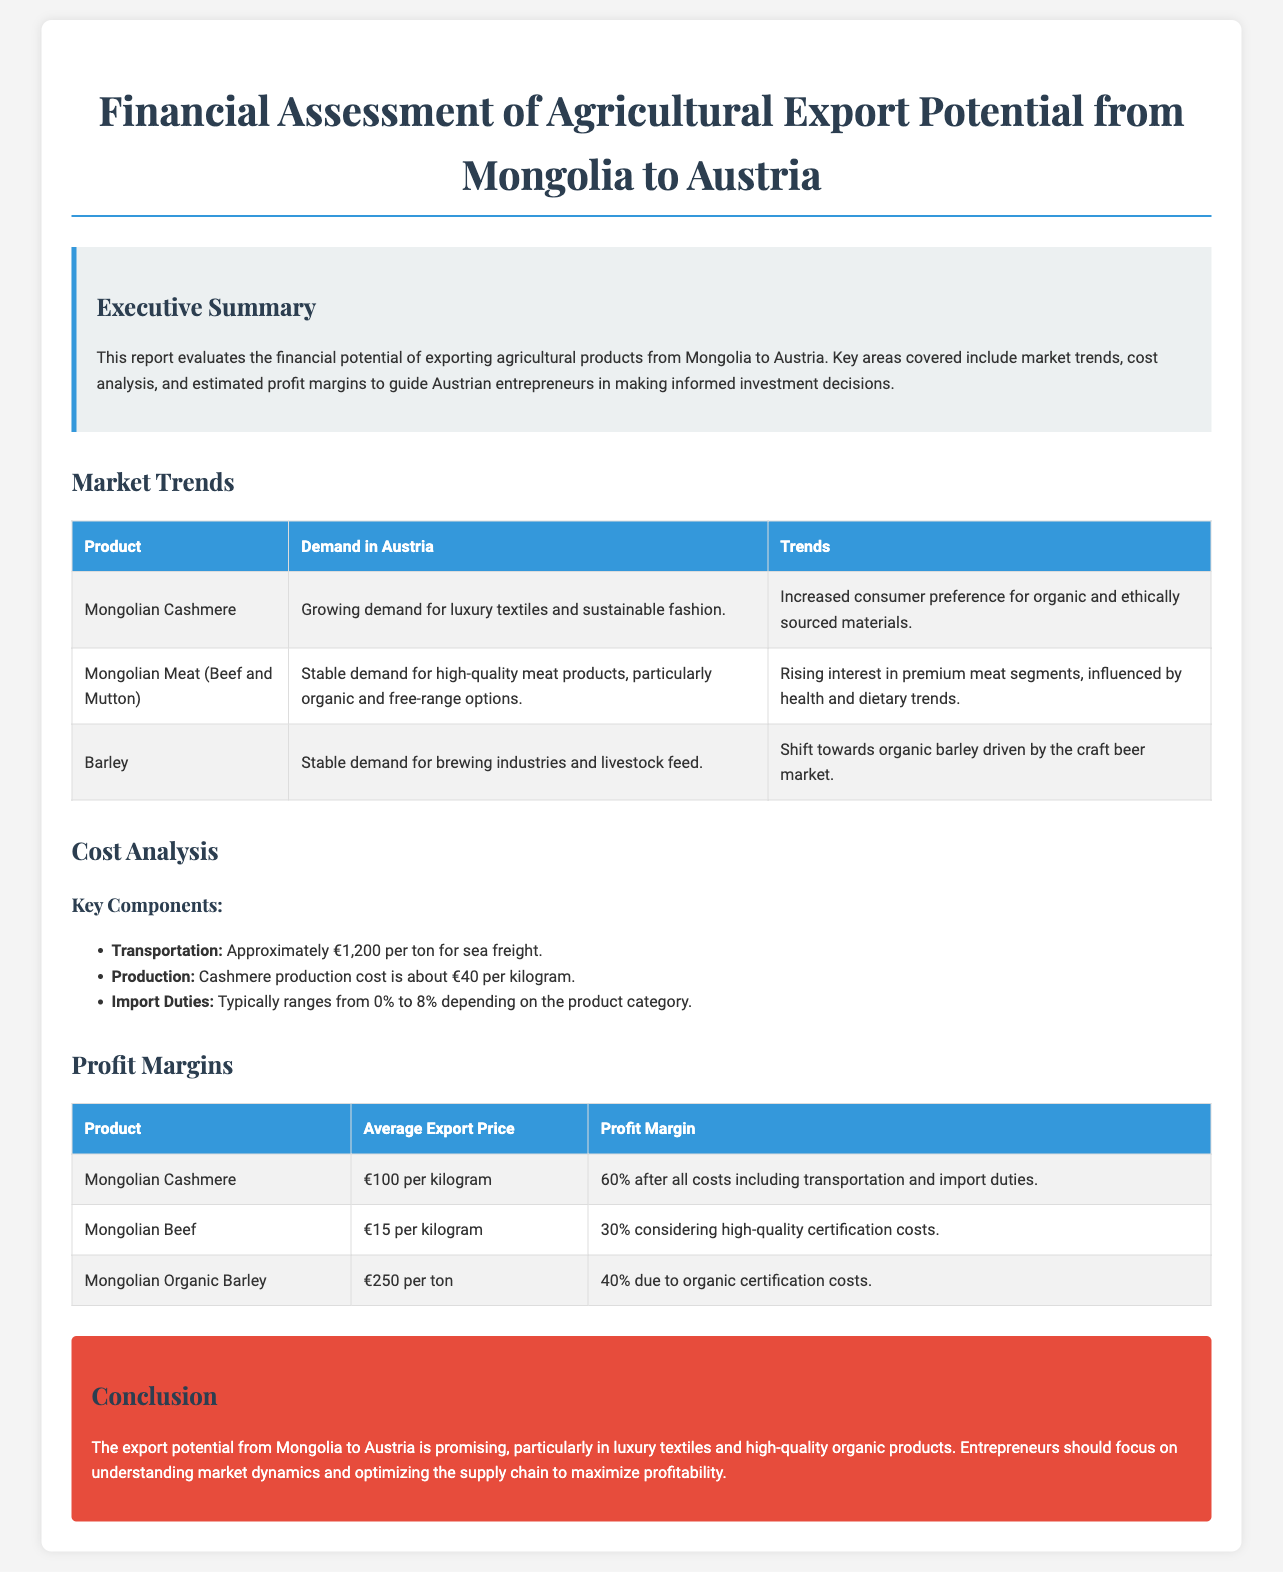What is the main focus of the report? The report evaluates the financial potential of exporting agricultural products from Mongolia to Austria.
Answer: Financial potential of exporting agricultural products What are the two types of Mongolian meat mentioned? The report specifically mentions beef and mutton.
Answer: Beef and Mutton What is the average export price of Mongolian Cashmere? The document states that the average export price of Mongolian Cashmere is €100 per kilogram.
Answer: €100 per kilogram What is the estimated profit margin for Mongolian Beef? The document indicates that the profit margin for Mongolian Beef is 30%.
Answer: 30% What trend is influencing the demand for Mongolian Barley? The report mentions a shift towards organic barley driven by the craft beer market.
Answer: Shift towards organic barley What is the transportation cost per ton for sea freight? The document states that the transportation cost is approximately €1,200 per ton for sea freight.
Answer: €1,200 per ton What product has a growing demand in Austria according to the report? The report highlights that there is a growing demand for Mongolian Cashmere in Austria.
Answer: Mongolian Cashmere How much do import duties typically range for products? The report notes that import duties typically range from 0% to 8%.
Answer: 0% to 8% What is a key suggestion for entrepreneurs in the conclusion? The conclusion advises entrepreneurs to focus on understanding market dynamics and optimizing the supply chain.
Answer: Understanding market dynamics and optimizing the supply chain 